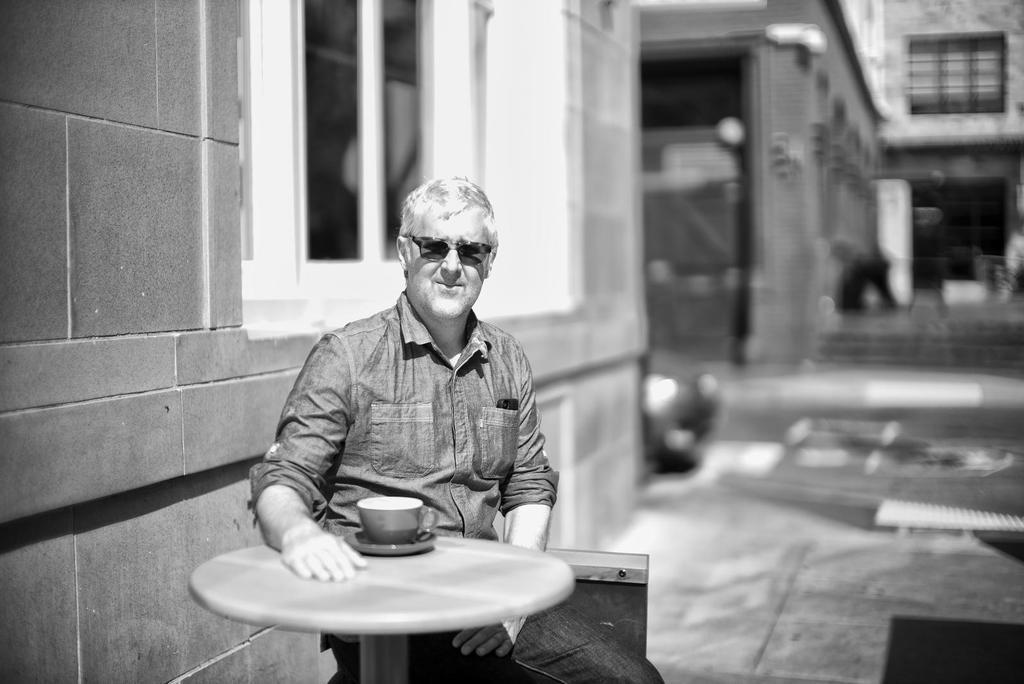Can you describe this image briefly? there is a person sitting in front of a table on the table there is a cup 